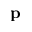Convert formula to latex. <formula><loc_0><loc_0><loc_500><loc_500>p</formula> 